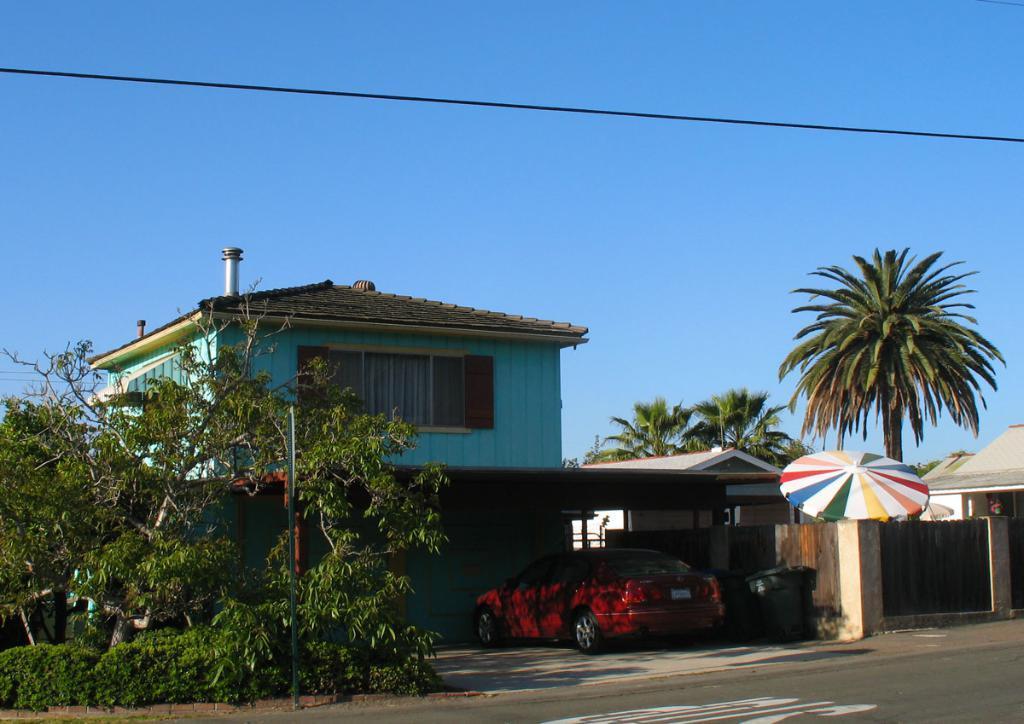Can you describe this image briefly? In this image, we can see few houses, walls, window, trees, pole, vehicle, umbrella. At the bottom, there is a road. Background we can see the sky. Here there is a wire. 